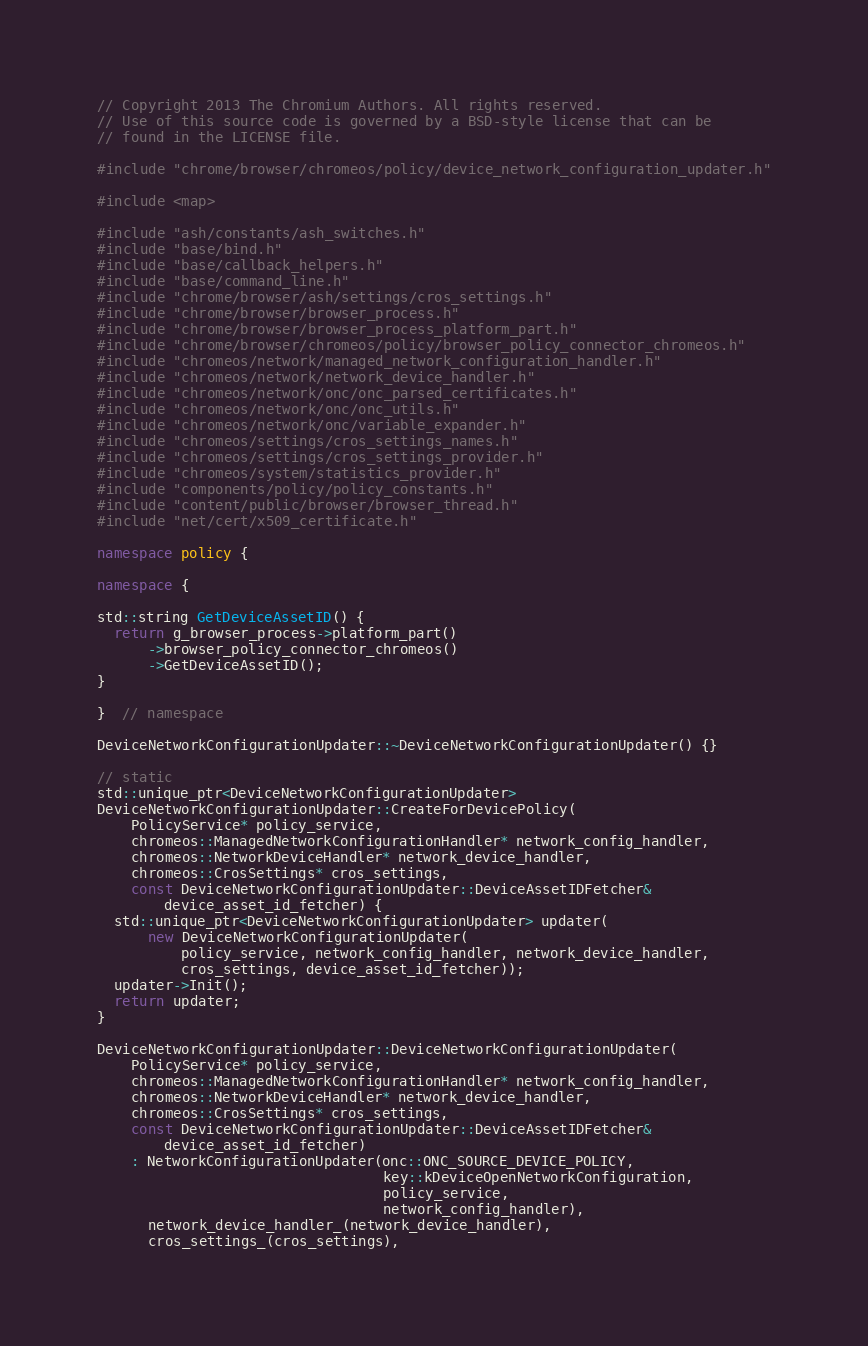Convert code to text. <code><loc_0><loc_0><loc_500><loc_500><_C++_>// Copyright 2013 The Chromium Authors. All rights reserved.
// Use of this source code is governed by a BSD-style license that can be
// found in the LICENSE file.

#include "chrome/browser/chromeos/policy/device_network_configuration_updater.h"

#include <map>

#include "ash/constants/ash_switches.h"
#include "base/bind.h"
#include "base/callback_helpers.h"
#include "base/command_line.h"
#include "chrome/browser/ash/settings/cros_settings.h"
#include "chrome/browser/browser_process.h"
#include "chrome/browser/browser_process_platform_part.h"
#include "chrome/browser/chromeos/policy/browser_policy_connector_chromeos.h"
#include "chromeos/network/managed_network_configuration_handler.h"
#include "chromeos/network/network_device_handler.h"
#include "chromeos/network/onc/onc_parsed_certificates.h"
#include "chromeos/network/onc/onc_utils.h"
#include "chromeos/network/onc/variable_expander.h"
#include "chromeos/settings/cros_settings_names.h"
#include "chromeos/settings/cros_settings_provider.h"
#include "chromeos/system/statistics_provider.h"
#include "components/policy/policy_constants.h"
#include "content/public/browser/browser_thread.h"
#include "net/cert/x509_certificate.h"

namespace policy {

namespace {

std::string GetDeviceAssetID() {
  return g_browser_process->platform_part()
      ->browser_policy_connector_chromeos()
      ->GetDeviceAssetID();
}

}  // namespace

DeviceNetworkConfigurationUpdater::~DeviceNetworkConfigurationUpdater() {}

// static
std::unique_ptr<DeviceNetworkConfigurationUpdater>
DeviceNetworkConfigurationUpdater::CreateForDevicePolicy(
    PolicyService* policy_service,
    chromeos::ManagedNetworkConfigurationHandler* network_config_handler,
    chromeos::NetworkDeviceHandler* network_device_handler,
    chromeos::CrosSettings* cros_settings,
    const DeviceNetworkConfigurationUpdater::DeviceAssetIDFetcher&
        device_asset_id_fetcher) {
  std::unique_ptr<DeviceNetworkConfigurationUpdater> updater(
      new DeviceNetworkConfigurationUpdater(
          policy_service, network_config_handler, network_device_handler,
          cros_settings, device_asset_id_fetcher));
  updater->Init();
  return updater;
}

DeviceNetworkConfigurationUpdater::DeviceNetworkConfigurationUpdater(
    PolicyService* policy_service,
    chromeos::ManagedNetworkConfigurationHandler* network_config_handler,
    chromeos::NetworkDeviceHandler* network_device_handler,
    chromeos::CrosSettings* cros_settings,
    const DeviceNetworkConfigurationUpdater::DeviceAssetIDFetcher&
        device_asset_id_fetcher)
    : NetworkConfigurationUpdater(onc::ONC_SOURCE_DEVICE_POLICY,
                                  key::kDeviceOpenNetworkConfiguration,
                                  policy_service,
                                  network_config_handler),
      network_device_handler_(network_device_handler),
      cros_settings_(cros_settings),</code> 